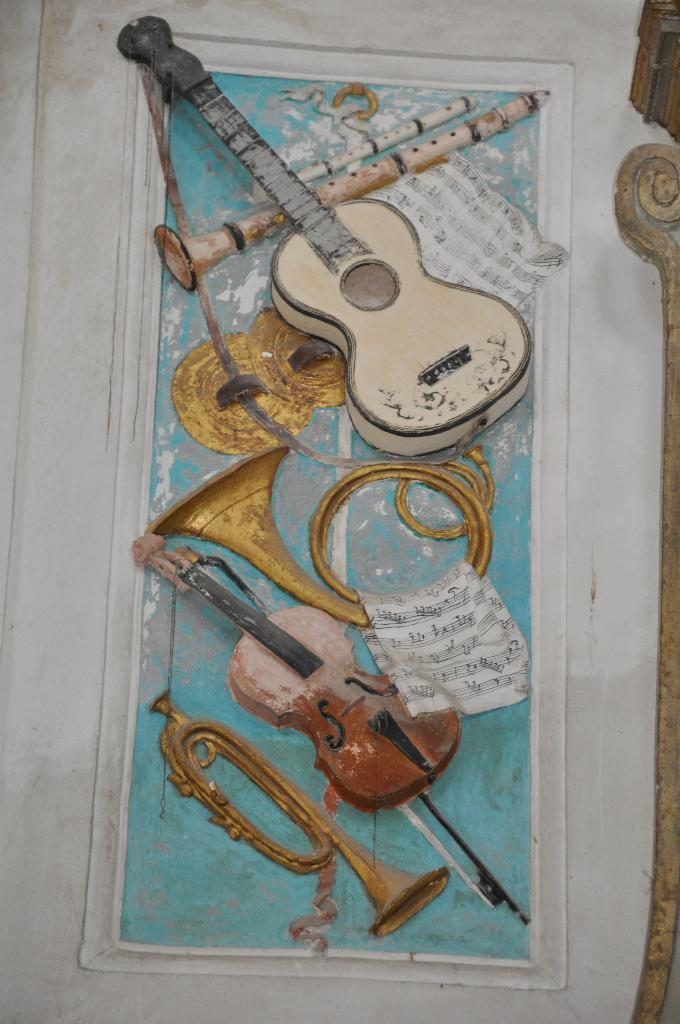What can be seen on the wall in the image? There is a wall with a design in the image. What else is present in the image besides the wall? There are musical instruments in the image. Can you describe the object on the right side of the image? Unfortunately, the facts provided do not give enough information to describe the object on the right side of the image. What type of disease is being treated at the hospital in the image? There is no hospital present in the image, so it is not possible to answer that question. 